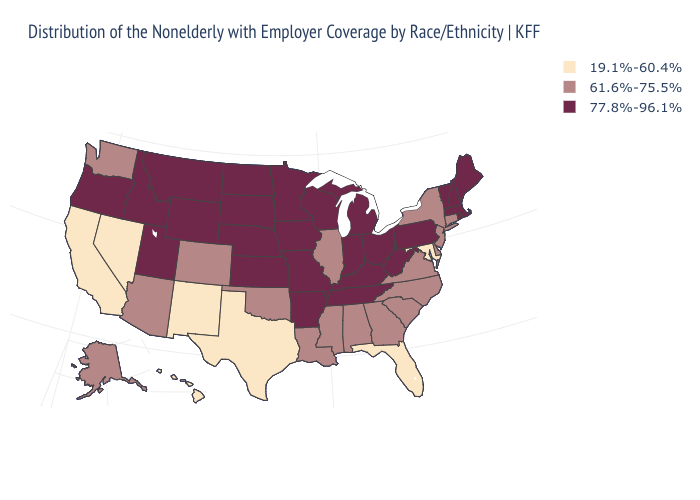Is the legend a continuous bar?
Concise answer only. No. Which states hav the highest value in the West?
Write a very short answer. Idaho, Montana, Oregon, Utah, Wyoming. What is the highest value in the MidWest ?
Give a very brief answer. 77.8%-96.1%. Name the states that have a value in the range 19.1%-60.4%?
Concise answer only. California, Florida, Hawaii, Maryland, Nevada, New Mexico, Texas. Is the legend a continuous bar?
Be succinct. No. Does South Dakota have a higher value than Texas?
Write a very short answer. Yes. What is the highest value in the MidWest ?
Write a very short answer. 77.8%-96.1%. What is the value of Utah?
Be succinct. 77.8%-96.1%. What is the value of North Carolina?
Concise answer only. 61.6%-75.5%. Name the states that have a value in the range 77.8%-96.1%?
Answer briefly. Arkansas, Idaho, Indiana, Iowa, Kansas, Kentucky, Maine, Massachusetts, Michigan, Minnesota, Missouri, Montana, Nebraska, New Hampshire, North Dakota, Ohio, Oregon, Pennsylvania, Rhode Island, South Dakota, Tennessee, Utah, Vermont, West Virginia, Wisconsin, Wyoming. Name the states that have a value in the range 61.6%-75.5%?
Answer briefly. Alabama, Alaska, Arizona, Colorado, Connecticut, Delaware, Georgia, Illinois, Louisiana, Mississippi, New Jersey, New York, North Carolina, Oklahoma, South Carolina, Virginia, Washington. Name the states that have a value in the range 61.6%-75.5%?
Write a very short answer. Alabama, Alaska, Arizona, Colorado, Connecticut, Delaware, Georgia, Illinois, Louisiana, Mississippi, New Jersey, New York, North Carolina, Oklahoma, South Carolina, Virginia, Washington. Is the legend a continuous bar?
Give a very brief answer. No. Name the states that have a value in the range 19.1%-60.4%?
Be succinct. California, Florida, Hawaii, Maryland, Nevada, New Mexico, Texas. Name the states that have a value in the range 77.8%-96.1%?
Give a very brief answer. Arkansas, Idaho, Indiana, Iowa, Kansas, Kentucky, Maine, Massachusetts, Michigan, Minnesota, Missouri, Montana, Nebraska, New Hampshire, North Dakota, Ohio, Oregon, Pennsylvania, Rhode Island, South Dakota, Tennessee, Utah, Vermont, West Virginia, Wisconsin, Wyoming. 